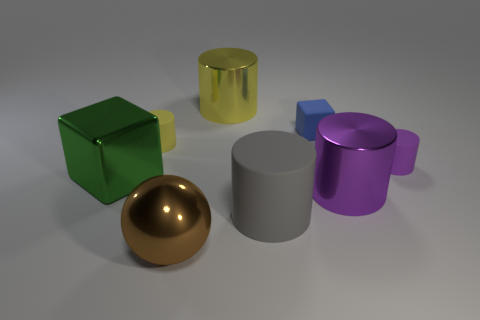The rubber cylinder that is the same size as the brown metallic sphere is what color?
Provide a short and direct response. Gray. The tiny matte thing that is in front of the yellow cylinder left of the big cylinder behind the green block is what shape?
Your answer should be very brief. Cylinder. How many things are either cylinders or cylinders that are behind the big gray thing?
Your response must be concise. 5. There is a purple object behind the purple metal thing; does it have the same size as the large green object?
Give a very brief answer. No. There is a block right of the big brown metallic ball; what material is it?
Your answer should be compact. Rubber. Is the number of large yellow cylinders that are to the right of the gray rubber object the same as the number of green objects that are on the right side of the small yellow rubber thing?
Your response must be concise. Yes. What color is the big matte thing that is the same shape as the small purple rubber thing?
Your answer should be very brief. Gray. Are there any other things that are the same color as the large shiny sphere?
Keep it short and to the point. No. What number of shiny objects are either tiny yellow blocks or small blue things?
Offer a very short reply. 0. Do the tiny cube and the ball have the same color?
Your response must be concise. No. 